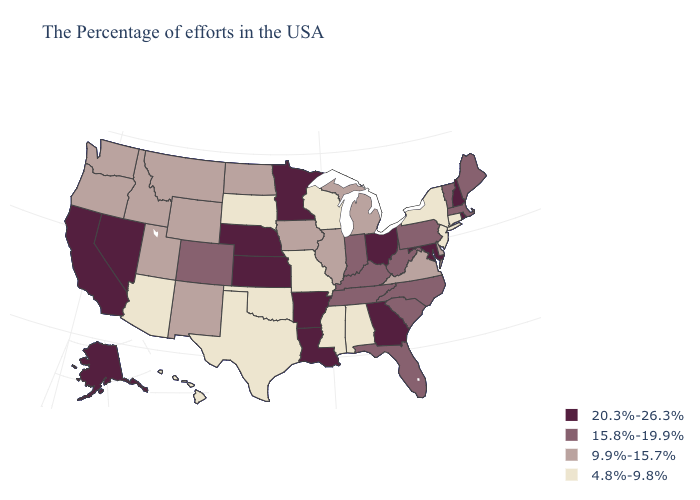Does the first symbol in the legend represent the smallest category?
Answer briefly. No. What is the value of Maryland?
Be succinct. 20.3%-26.3%. Name the states that have a value in the range 15.8%-19.9%?
Answer briefly. Maine, Massachusetts, Vermont, Pennsylvania, North Carolina, South Carolina, West Virginia, Florida, Kentucky, Indiana, Tennessee, Colorado. Name the states that have a value in the range 15.8%-19.9%?
Give a very brief answer. Maine, Massachusetts, Vermont, Pennsylvania, North Carolina, South Carolina, West Virginia, Florida, Kentucky, Indiana, Tennessee, Colorado. Which states have the lowest value in the USA?
Keep it brief. Connecticut, New York, New Jersey, Alabama, Wisconsin, Mississippi, Missouri, Oklahoma, Texas, South Dakota, Arizona, Hawaii. Is the legend a continuous bar?
Concise answer only. No. Does Arizona have a lower value than Alabama?
Be succinct. No. Does Minnesota have the highest value in the USA?
Be succinct. Yes. What is the value of Indiana?
Concise answer only. 15.8%-19.9%. Which states have the lowest value in the USA?
Concise answer only. Connecticut, New York, New Jersey, Alabama, Wisconsin, Mississippi, Missouri, Oklahoma, Texas, South Dakota, Arizona, Hawaii. What is the value of Maryland?
Write a very short answer. 20.3%-26.3%. What is the value of Delaware?
Be succinct. 9.9%-15.7%. What is the highest value in the USA?
Be succinct. 20.3%-26.3%. What is the value of Delaware?
Short answer required. 9.9%-15.7%. 